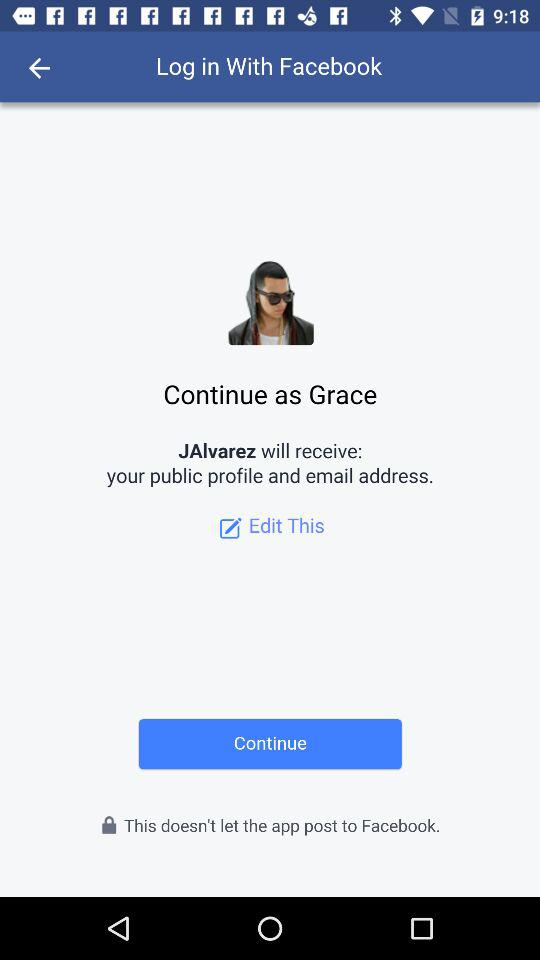What application is asking for permission? The application is "JAIvarez". 